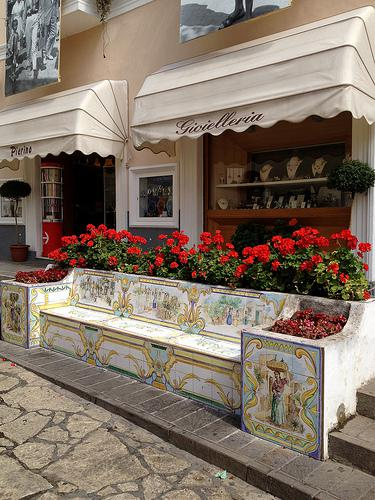Question: what is on the sign?
Choices:
A. A monkey.
B. Ape.
C. Gioielleria.
D. Horse.
Answer with the letter. Answer: C Question: where are the flowers?
Choices:
A. Behind the chair.
B. Under the bench.
C. On the bench.
D. Behind the bench.
Answer with the letter. Answer: D Question: how many benches?
Choices:
A. One.
B. Two.
C. Three.
D. Zero.
Answer with the letter. Answer: A Question: what type of street?
Choices:
A. Stone.
B. Brick.
C. Rock.
D. Pebble.
Answer with the letter. Answer: A 